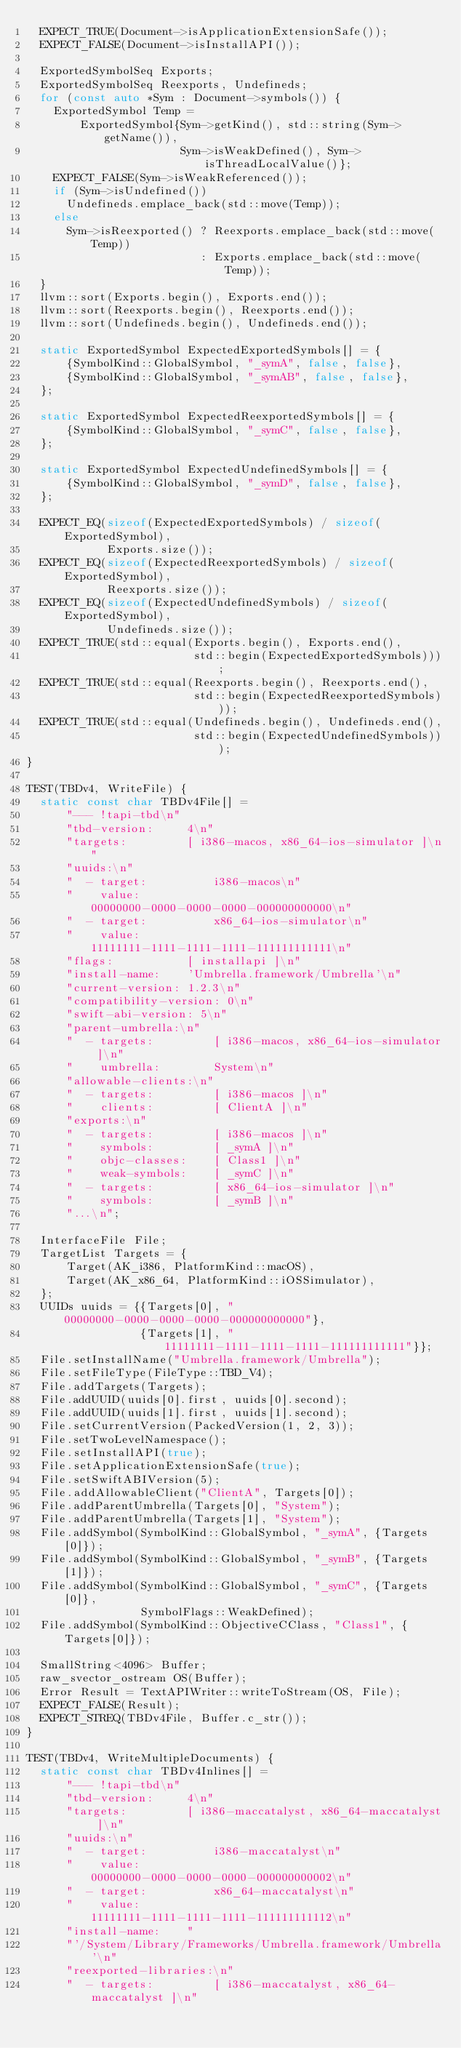Convert code to text. <code><loc_0><loc_0><loc_500><loc_500><_C++_>  EXPECT_TRUE(Document->isApplicationExtensionSafe());
  EXPECT_FALSE(Document->isInstallAPI());

  ExportedSymbolSeq Exports;
  ExportedSymbolSeq Reexports, Undefineds;
  for (const auto *Sym : Document->symbols()) {
    ExportedSymbol Temp =
        ExportedSymbol{Sym->getKind(), std::string(Sym->getName()),
                       Sym->isWeakDefined(), Sym->isThreadLocalValue()};
    EXPECT_FALSE(Sym->isWeakReferenced());
    if (Sym->isUndefined())
      Undefineds.emplace_back(std::move(Temp));
    else
      Sym->isReexported() ? Reexports.emplace_back(std::move(Temp))
                          : Exports.emplace_back(std::move(Temp));
  }
  llvm::sort(Exports.begin(), Exports.end());
  llvm::sort(Reexports.begin(), Reexports.end());
  llvm::sort(Undefineds.begin(), Undefineds.end());

  static ExportedSymbol ExpectedExportedSymbols[] = {
      {SymbolKind::GlobalSymbol, "_symA", false, false},
      {SymbolKind::GlobalSymbol, "_symAB", false, false},
  };

  static ExportedSymbol ExpectedReexportedSymbols[] = {
      {SymbolKind::GlobalSymbol, "_symC", false, false},
  };

  static ExportedSymbol ExpectedUndefinedSymbols[] = {
      {SymbolKind::GlobalSymbol, "_symD", false, false},
  };

  EXPECT_EQ(sizeof(ExpectedExportedSymbols) / sizeof(ExportedSymbol),
            Exports.size());
  EXPECT_EQ(sizeof(ExpectedReexportedSymbols) / sizeof(ExportedSymbol),
            Reexports.size());
  EXPECT_EQ(sizeof(ExpectedUndefinedSymbols) / sizeof(ExportedSymbol),
            Undefineds.size());
  EXPECT_TRUE(std::equal(Exports.begin(), Exports.end(),
                         std::begin(ExpectedExportedSymbols)));
  EXPECT_TRUE(std::equal(Reexports.begin(), Reexports.end(),
                         std::begin(ExpectedReexportedSymbols)));
  EXPECT_TRUE(std::equal(Undefineds.begin(), Undefineds.end(),
                         std::begin(ExpectedUndefinedSymbols)));
}

TEST(TBDv4, WriteFile) {
  static const char TBDv4File[] =
      "--- !tapi-tbd\n"
      "tbd-version:     4\n"
      "targets:         [ i386-macos, x86_64-ios-simulator ]\n"
      "uuids:\n"
      "  - target:          i386-macos\n"
      "    value:           00000000-0000-0000-0000-000000000000\n"
      "  - target:          x86_64-ios-simulator\n"
      "    value:           11111111-1111-1111-1111-111111111111\n"
      "flags:           [ installapi ]\n"
      "install-name:    'Umbrella.framework/Umbrella'\n"
      "current-version: 1.2.3\n"
      "compatibility-version: 0\n"
      "swift-abi-version: 5\n"
      "parent-umbrella:\n"
      "  - targets:         [ i386-macos, x86_64-ios-simulator ]\n"
      "    umbrella:        System\n"
      "allowable-clients:\n"
      "  - targets:         [ i386-macos ]\n"
      "    clients:         [ ClientA ]\n"
      "exports:\n"
      "  - targets:         [ i386-macos ]\n"
      "    symbols:         [ _symA ]\n"
      "    objc-classes:    [ Class1 ]\n"
      "    weak-symbols:    [ _symC ]\n"
      "  - targets:         [ x86_64-ios-simulator ]\n"
      "    symbols:         [ _symB ]\n"
      "...\n";

  InterfaceFile File;
  TargetList Targets = {
      Target(AK_i386, PlatformKind::macOS),
      Target(AK_x86_64, PlatformKind::iOSSimulator),
  };
  UUIDs uuids = {{Targets[0], "00000000-0000-0000-0000-000000000000"},
                 {Targets[1], "11111111-1111-1111-1111-111111111111"}};
  File.setInstallName("Umbrella.framework/Umbrella");
  File.setFileType(FileType::TBD_V4);
  File.addTargets(Targets);
  File.addUUID(uuids[0].first, uuids[0].second);
  File.addUUID(uuids[1].first, uuids[1].second);
  File.setCurrentVersion(PackedVersion(1, 2, 3));
  File.setTwoLevelNamespace();
  File.setInstallAPI(true);
  File.setApplicationExtensionSafe(true);
  File.setSwiftABIVersion(5);
  File.addAllowableClient("ClientA", Targets[0]);
  File.addParentUmbrella(Targets[0], "System");
  File.addParentUmbrella(Targets[1], "System");
  File.addSymbol(SymbolKind::GlobalSymbol, "_symA", {Targets[0]});
  File.addSymbol(SymbolKind::GlobalSymbol, "_symB", {Targets[1]});
  File.addSymbol(SymbolKind::GlobalSymbol, "_symC", {Targets[0]},
                 SymbolFlags::WeakDefined);
  File.addSymbol(SymbolKind::ObjectiveCClass, "Class1", {Targets[0]});

  SmallString<4096> Buffer;
  raw_svector_ostream OS(Buffer);
  Error Result = TextAPIWriter::writeToStream(OS, File);
  EXPECT_FALSE(Result);
  EXPECT_STREQ(TBDv4File, Buffer.c_str());
}

TEST(TBDv4, WriteMultipleDocuments) {
  static const char TBDv4Inlines[] =
      "--- !tapi-tbd\n"
      "tbd-version:     4\n"
      "targets:         [ i386-maccatalyst, x86_64-maccatalyst ]\n"
      "uuids:\n"
      "  - target:          i386-maccatalyst\n"
      "    value:           00000000-0000-0000-0000-000000000002\n"
      "  - target:          x86_64-maccatalyst\n"
      "    value:           11111111-1111-1111-1111-111111111112\n"
      "install-name:    "
      "'/System/Library/Frameworks/Umbrella.framework/Umbrella'\n"
      "reexported-libraries:\n"
      "  - targets:         [ i386-maccatalyst, x86_64-maccatalyst ]\n"</code> 